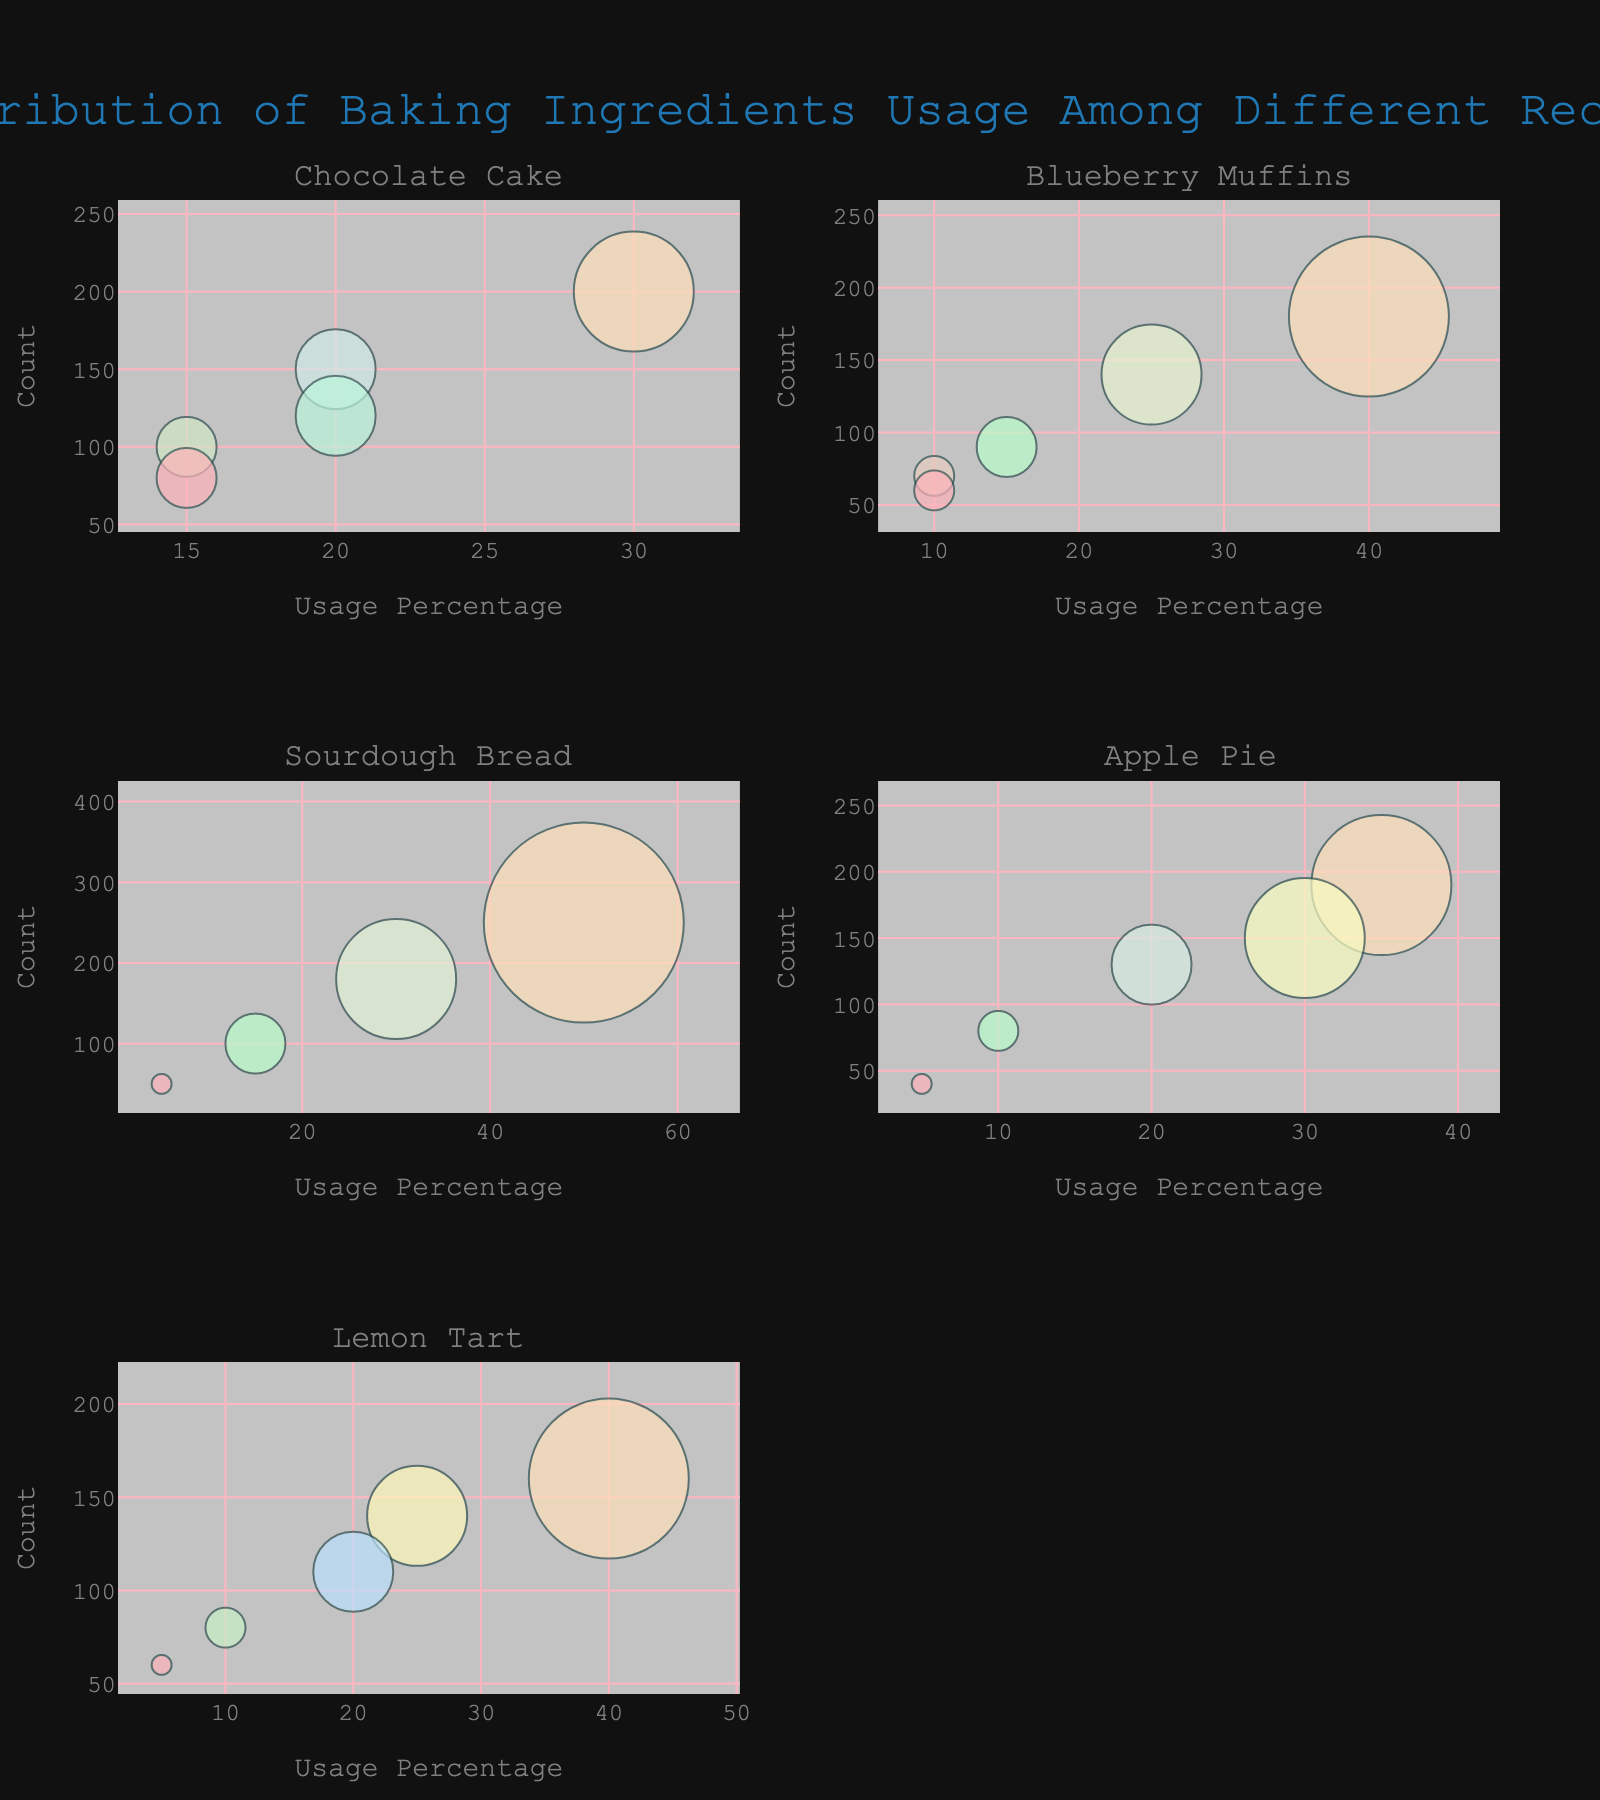What is the title of the chart? The title of the chart appears at the top and summarizes the content. It often provides the first insight into what the viewer is about to explore in the plot.
Answer: Distribution of Baking Ingredients Usage Among Different Recipes How many recipes are displayed in the subplots? The recipes are unique and divided into separate subplots for each distinct recipe. Each subplot title gives clues to the number of recipes displayed. By counting these titles, we derive the number of recipes.
Answer: 5 Which recipe uses the highest percentage of a single ingredient, and what is the ingredient? Look at each subplot and find the bubble with the highest x-value (usage percentage). Identify the corresponding ingredient for that bubble.
Answer: Sourdough Bread uses the highest percentage of Flour (50%) Which recipe has the smallest bubble size for one of its ingredients, and what is the ingredient? The bubble size is proportional to the usage percentage. Locate the subplot with the smallest bubble and check the associated ingredient and recipe from the hover data or color differences.
Answer: Lemon Tart with Eggs How do the usage percentages of Sugar compare between Chocolate Cake and Lemon Tart? Examine the bubbles associated with ‘Sugar’ in both subplots. Check the x-values (usage percentages) of these bubbles. Compare these x-values to find which is higher.
Answer: Chocolate Cake (20%) is lower than Lemon Tart (25%) Which ingredients have bubbles with both the smallest size and the lowest count within a recipe? Identify the smallest bubbles across all subplots by visually inspecting their size and y-values (count). Cross-reference these with the ingredients list for the corresponding recipe.
Answer: Cinnamon in Apple Pie and Eggs in Lemon Tart (both usage percentage 5% and low count) 